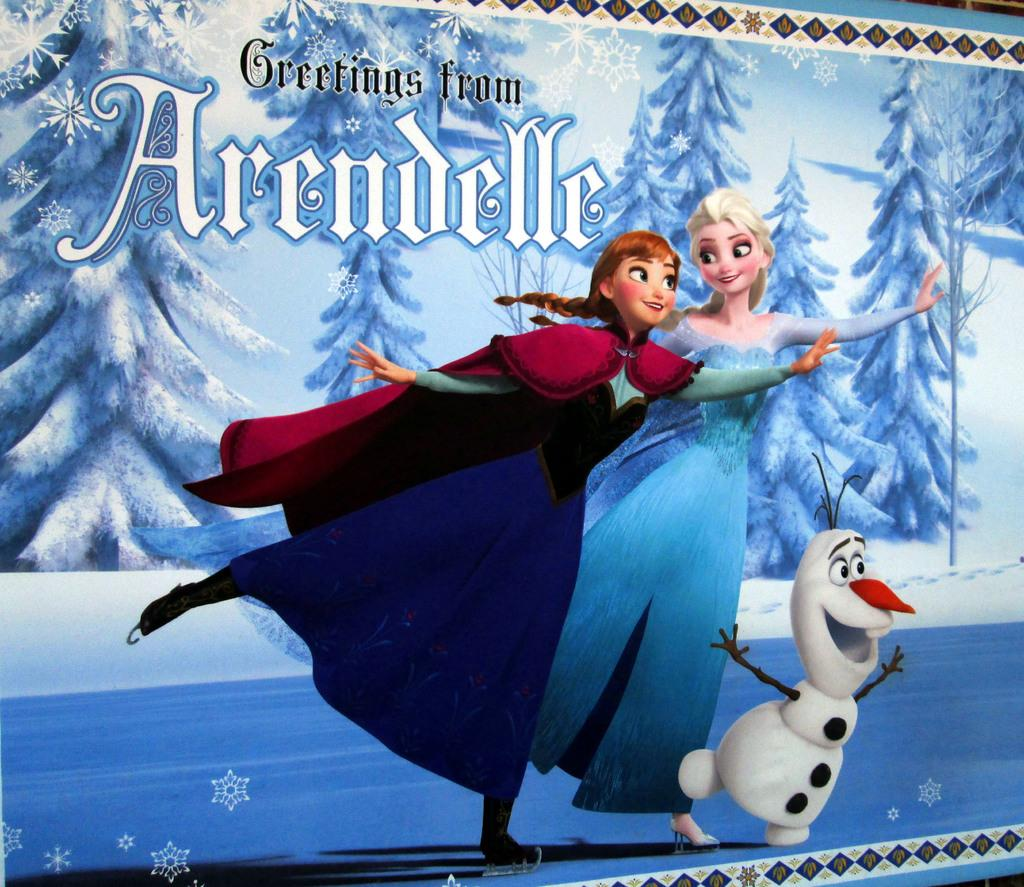<image>
Provide a brief description of the given image. The message on the post card is a greetings from Arendelle. 